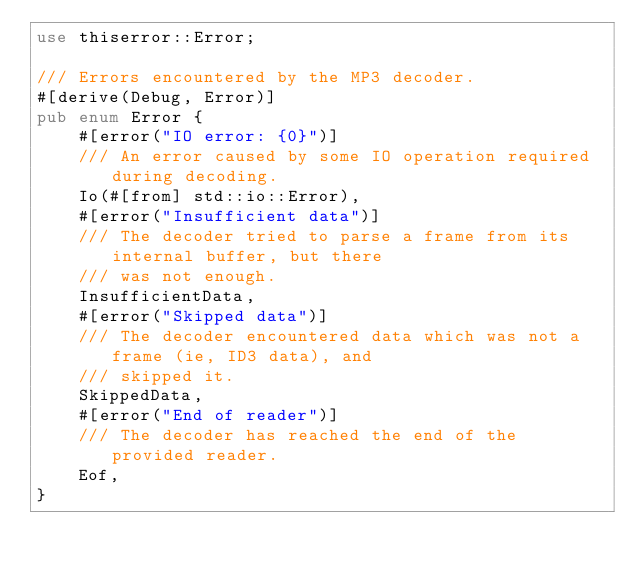Convert code to text. <code><loc_0><loc_0><loc_500><loc_500><_Rust_>use thiserror::Error;

/// Errors encountered by the MP3 decoder.
#[derive(Debug, Error)]
pub enum Error {
    #[error("IO error: {0}")]
    /// An error caused by some IO operation required during decoding.
    Io(#[from] std::io::Error),
    #[error("Insufficient data")]
    /// The decoder tried to parse a frame from its internal buffer, but there
    /// was not enough.
    InsufficientData,
    #[error("Skipped data")]
    /// The decoder encountered data which was not a frame (ie, ID3 data), and
    /// skipped it.
    SkippedData,
    #[error("End of reader")]
    /// The decoder has reached the end of the provided reader.
    Eof,
}
</code> 